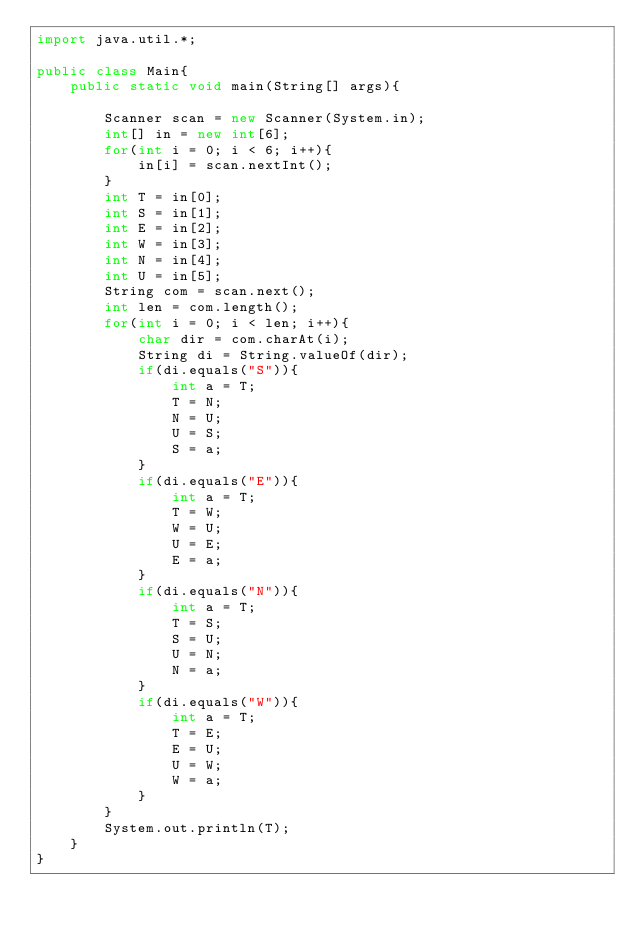<code> <loc_0><loc_0><loc_500><loc_500><_Java_>import java.util.*;

public class Main{
	public static void main(String[] args){

		Scanner scan = new Scanner(System.in);
		int[] in = new int[6];
		for(int i = 0; i < 6; i++){
			in[i] = scan.nextInt();
		}
		int T = in[0];
		int S = in[1];
		int E = in[2];
		int W = in[3];
		int N = in[4];
		int U = in[5];
		String com = scan.next();
		int len = com.length();
		for(int i = 0; i < len; i++){
			char dir = com.charAt(i);
			String di = String.valueOf(dir);
			if(di.equals("S")){
				int a = T;
				T = N;
				N = U;
				U = S;
				S = a;
			}
			if(di.equals("E")){
				int a = T;
				T = W;
				W = U;
				U = E;
				E = a;
			}
			if(di.equals("N")){
				int a = T;
				T = S;
				S = U;
				U = N;
				N = a;
			}
			if(di.equals("W")){
				int a = T;
				T = E;
				E = U;
				U = W;
				W = a;
			}
		}
		System.out.println(T);
	}
}</code> 